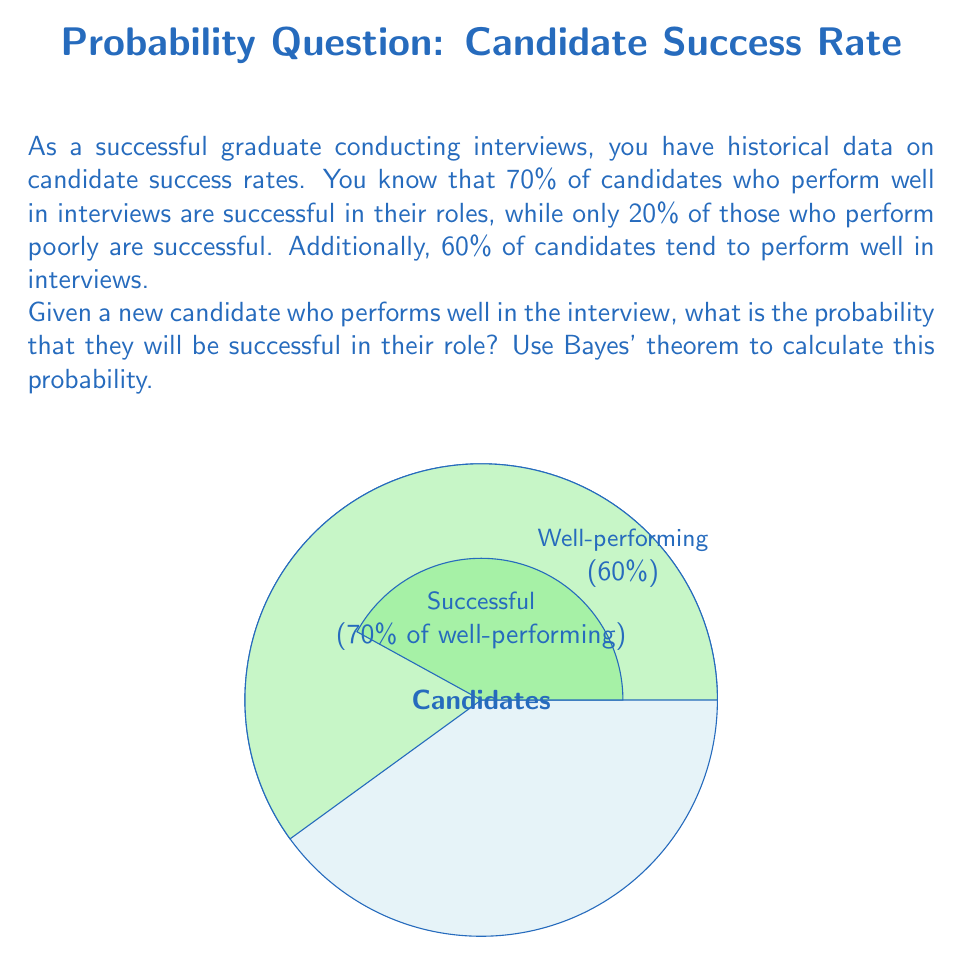What is the answer to this math problem? Let's approach this step-by-step using Bayes' theorem:

1) Define our events:
   $A$: The candidate is successful
   $B$: The candidate performs well in the interview

2) We're given:
   $P(A|B) = 0.70$ (70% of well-performing candidates are successful)
   $P(A|\neg B) = 0.20$ (20% of poorly-performing candidates are successful)
   $P(B) = 0.60$ (60% of candidates perform well)

3) We want to find $P(A|B)$, which is given by Bayes' theorem:

   $$P(A|B) = \frac{P(B|A)P(A)}{P(B)}$$

4) We need to find $P(B|A)$ and $P(A)$:

   For $P(A)$, we can use the law of total probability:
   $$P(A) = P(A|B)P(B) + P(A|\neg B)P(\neg B)$$
   $$P(A) = 0.70 \cdot 0.60 + 0.20 \cdot 0.40 = 0.42 + 0.08 = 0.50$$

   For $P(B|A)$, we can use Bayes' theorem again:
   $$P(B|A) = \frac{P(A|B)P(B)}{P(A)} = \frac{0.70 \cdot 0.60}{0.50} = 0.84$$

5) Now we can plug everything into Bayes' theorem:

   $$P(A|B) = \frac{0.84 \cdot 0.50}{0.60} = 0.70$$

Therefore, the probability that a candidate who performs well in the interview will be successful in their role is 0.70 or 70%.
Answer: $0.70$ or $70\%$ 